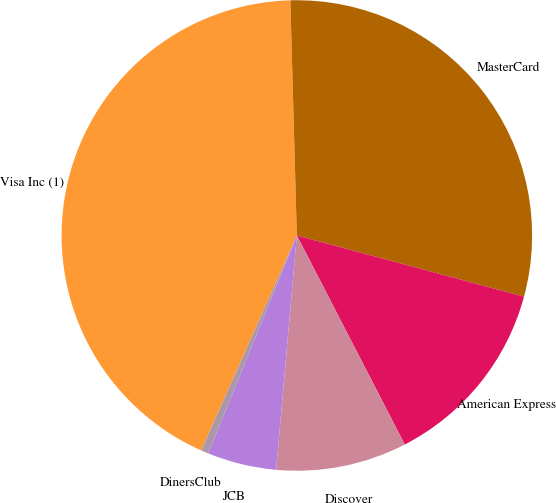<chart> <loc_0><loc_0><loc_500><loc_500><pie_chart><fcel>Visa Inc (1)<fcel>MasterCard<fcel>American Express<fcel>Discover<fcel>JCB<fcel>DinersClub<nl><fcel>42.9%<fcel>29.63%<fcel>13.23%<fcel>8.99%<fcel>4.75%<fcel>0.51%<nl></chart> 